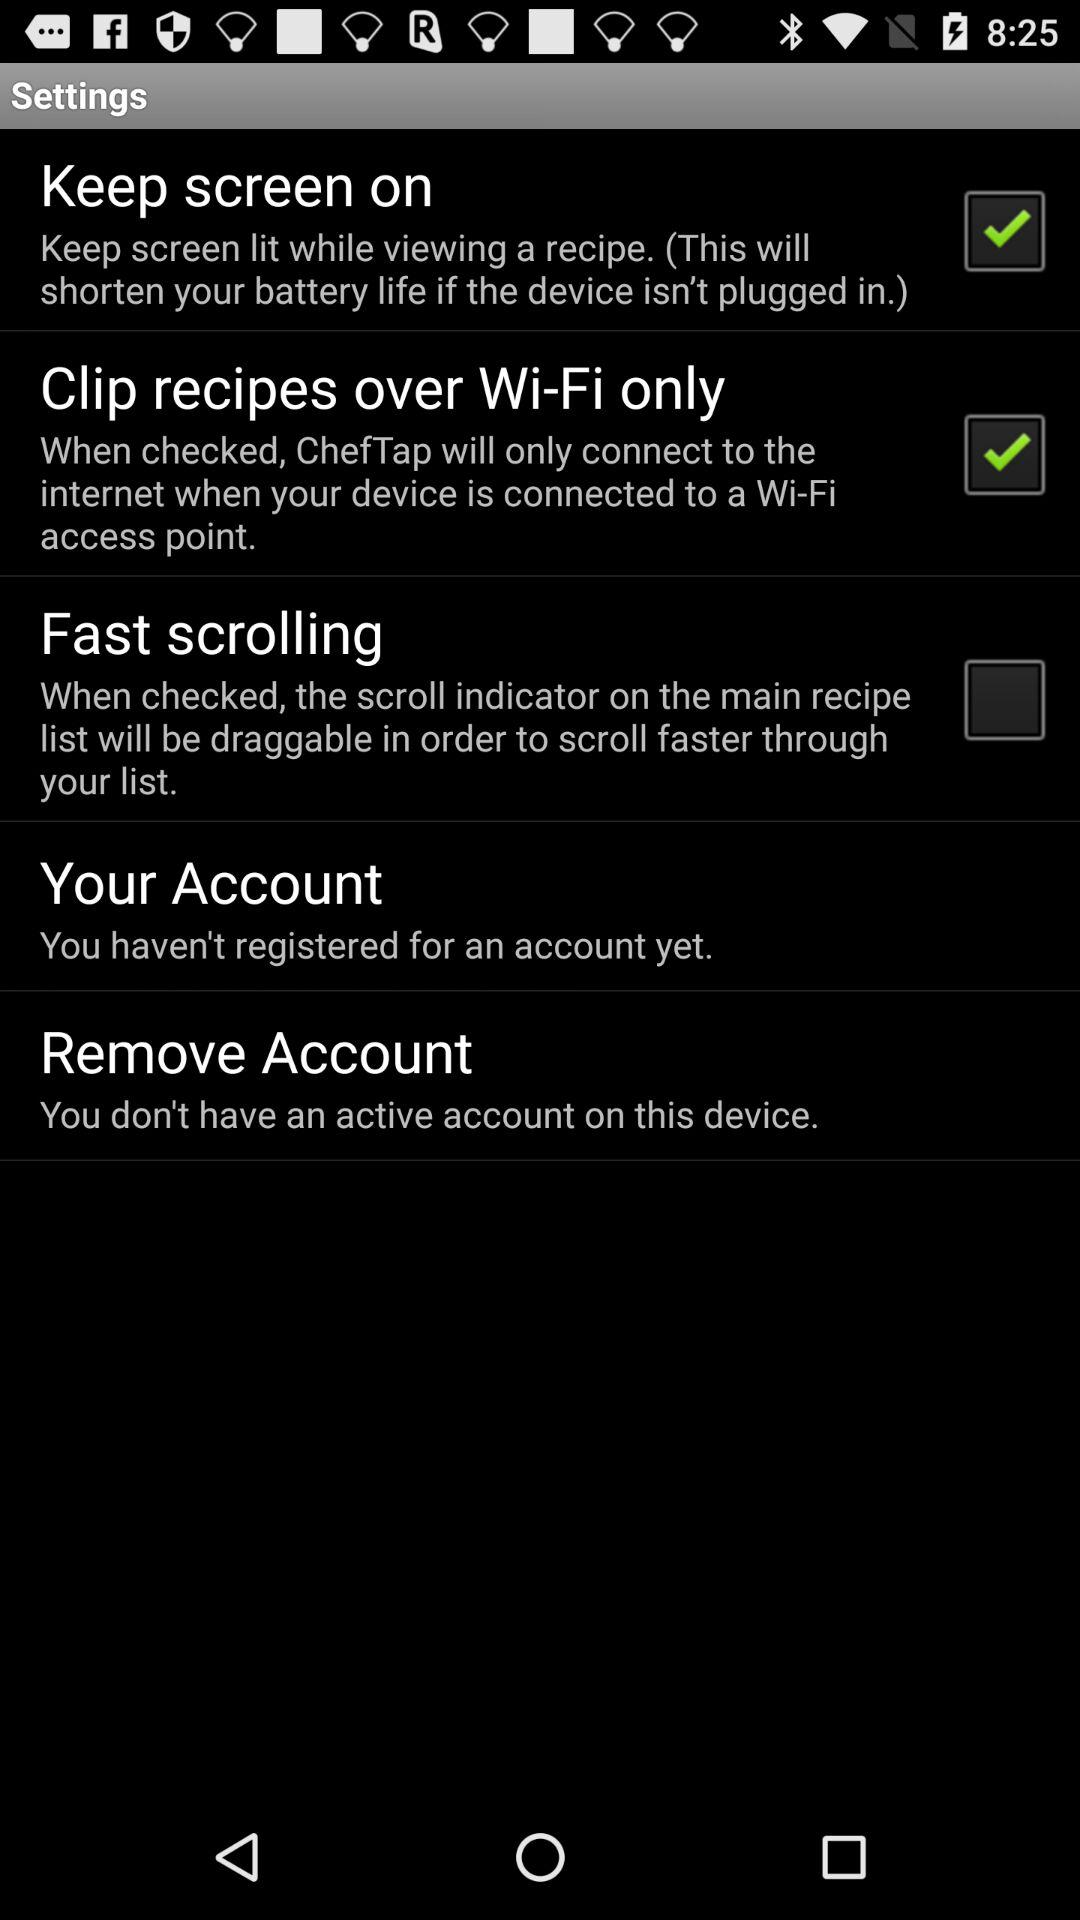What is the name of the application? The name of the application is "ChefTap". 